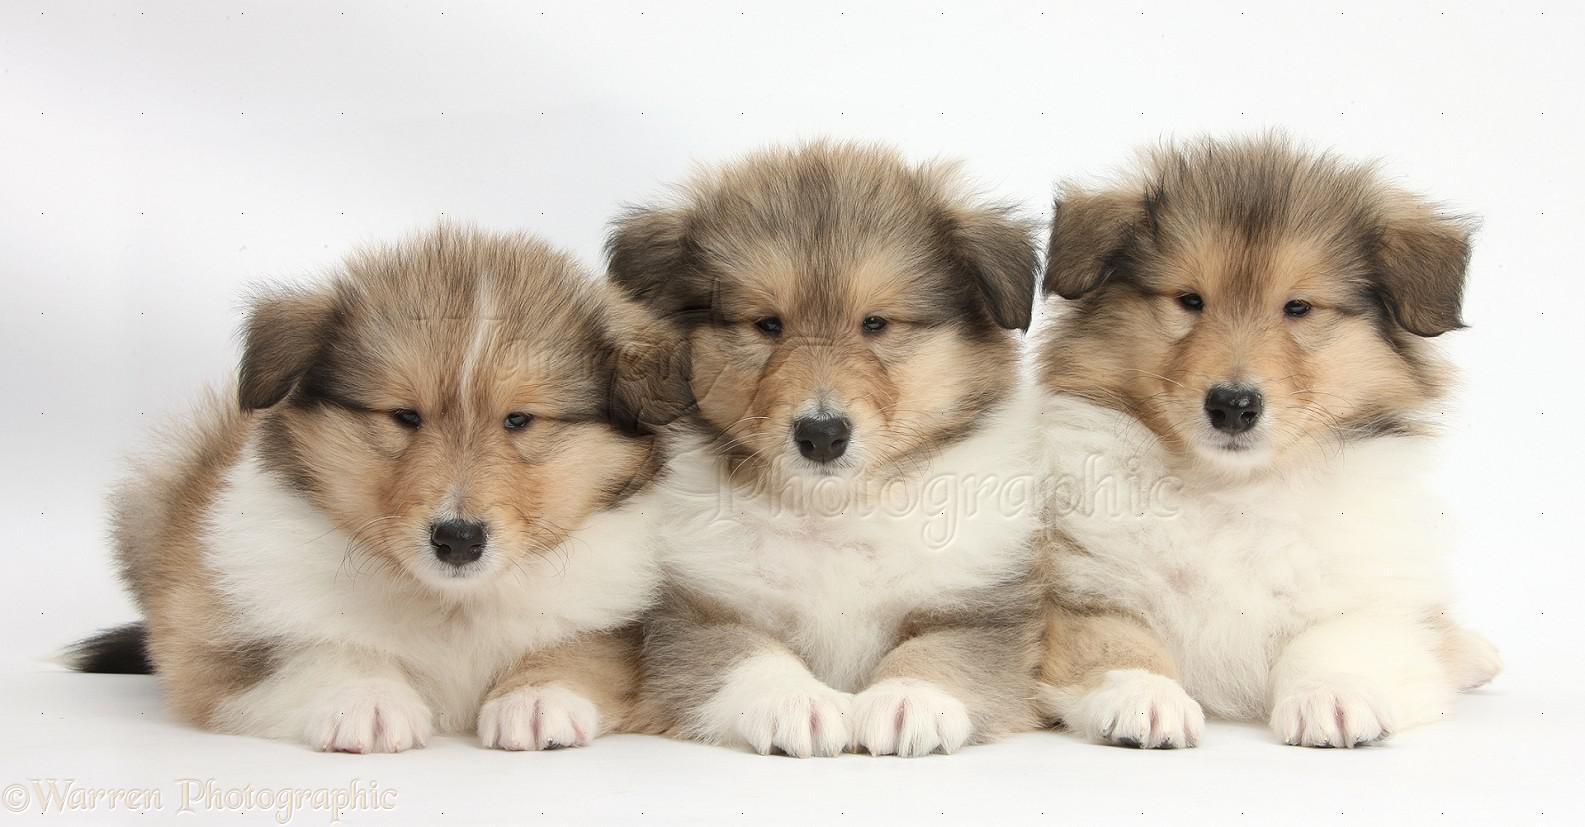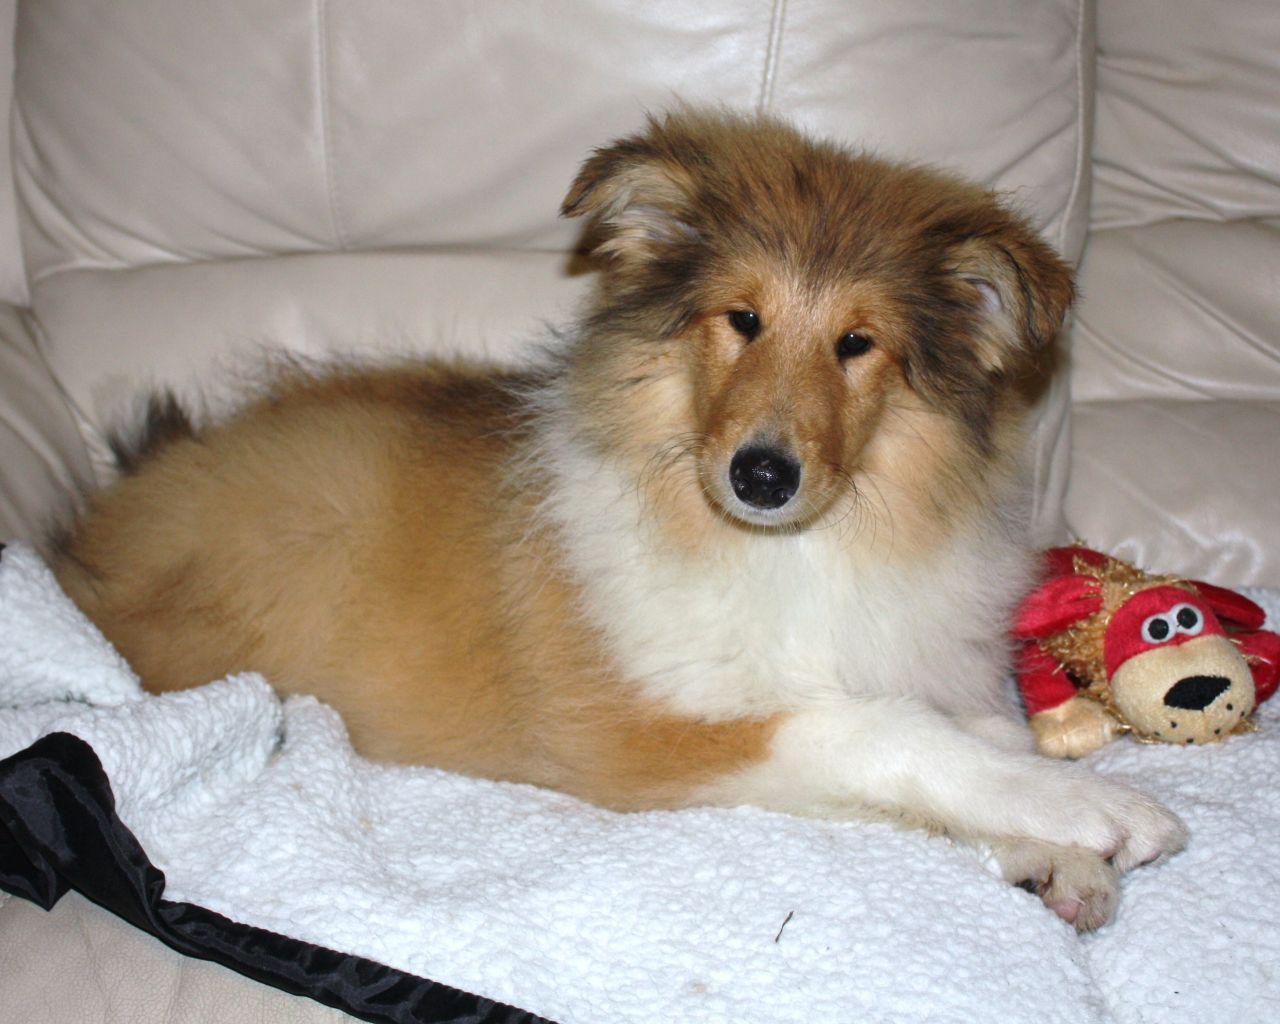The first image is the image on the left, the second image is the image on the right. For the images displayed, is the sentence "The right image contains exactly two dogs." factually correct? Answer yes or no. No. The first image is the image on the left, the second image is the image on the right. Assess this claim about the two images: "A reclining adult collie is posed alongside a collie pup sitting upright.". Correct or not? Answer yes or no. No. 